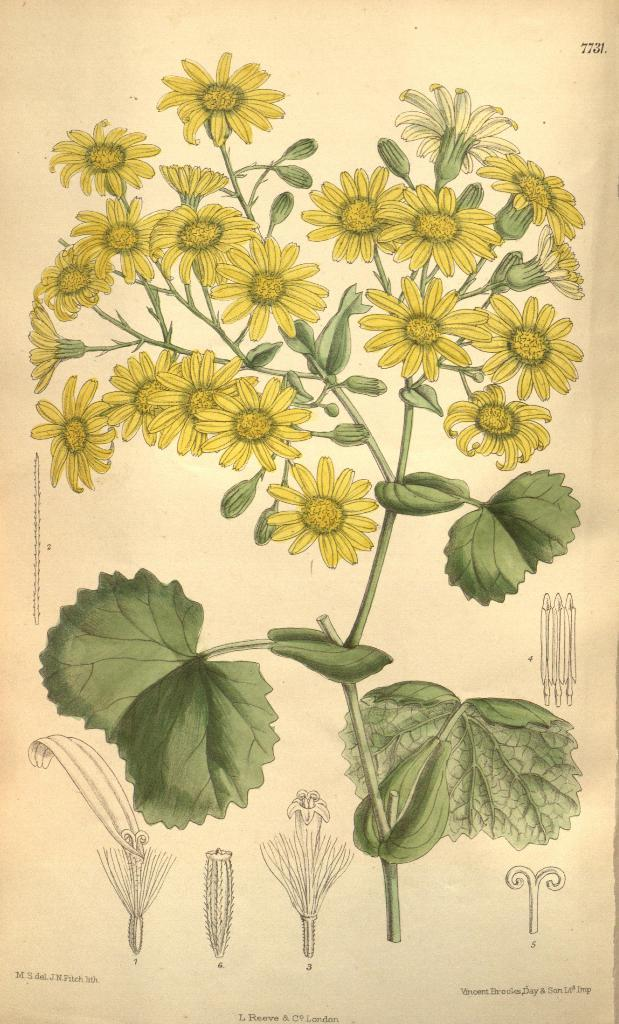What is depicted in the painting in the image? The painting in the image contains a plant. What features of the plant can be observed? The plant has flowers and leaves. What else can be seen at the bottom of the image? There are drawings and text at the bottom of the image. What type of brake system is installed on the plant in the image? There is no brake system present in the image, as it features a painting of a plant with flowers and leaves. How many mice can be seen interacting with the plant in the image? There are no mice present in the image; it only contains a painting of a plant. 